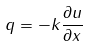Convert formula to latex. <formula><loc_0><loc_0><loc_500><loc_500>q = - k \frac { \partial u } { \partial x }</formula> 